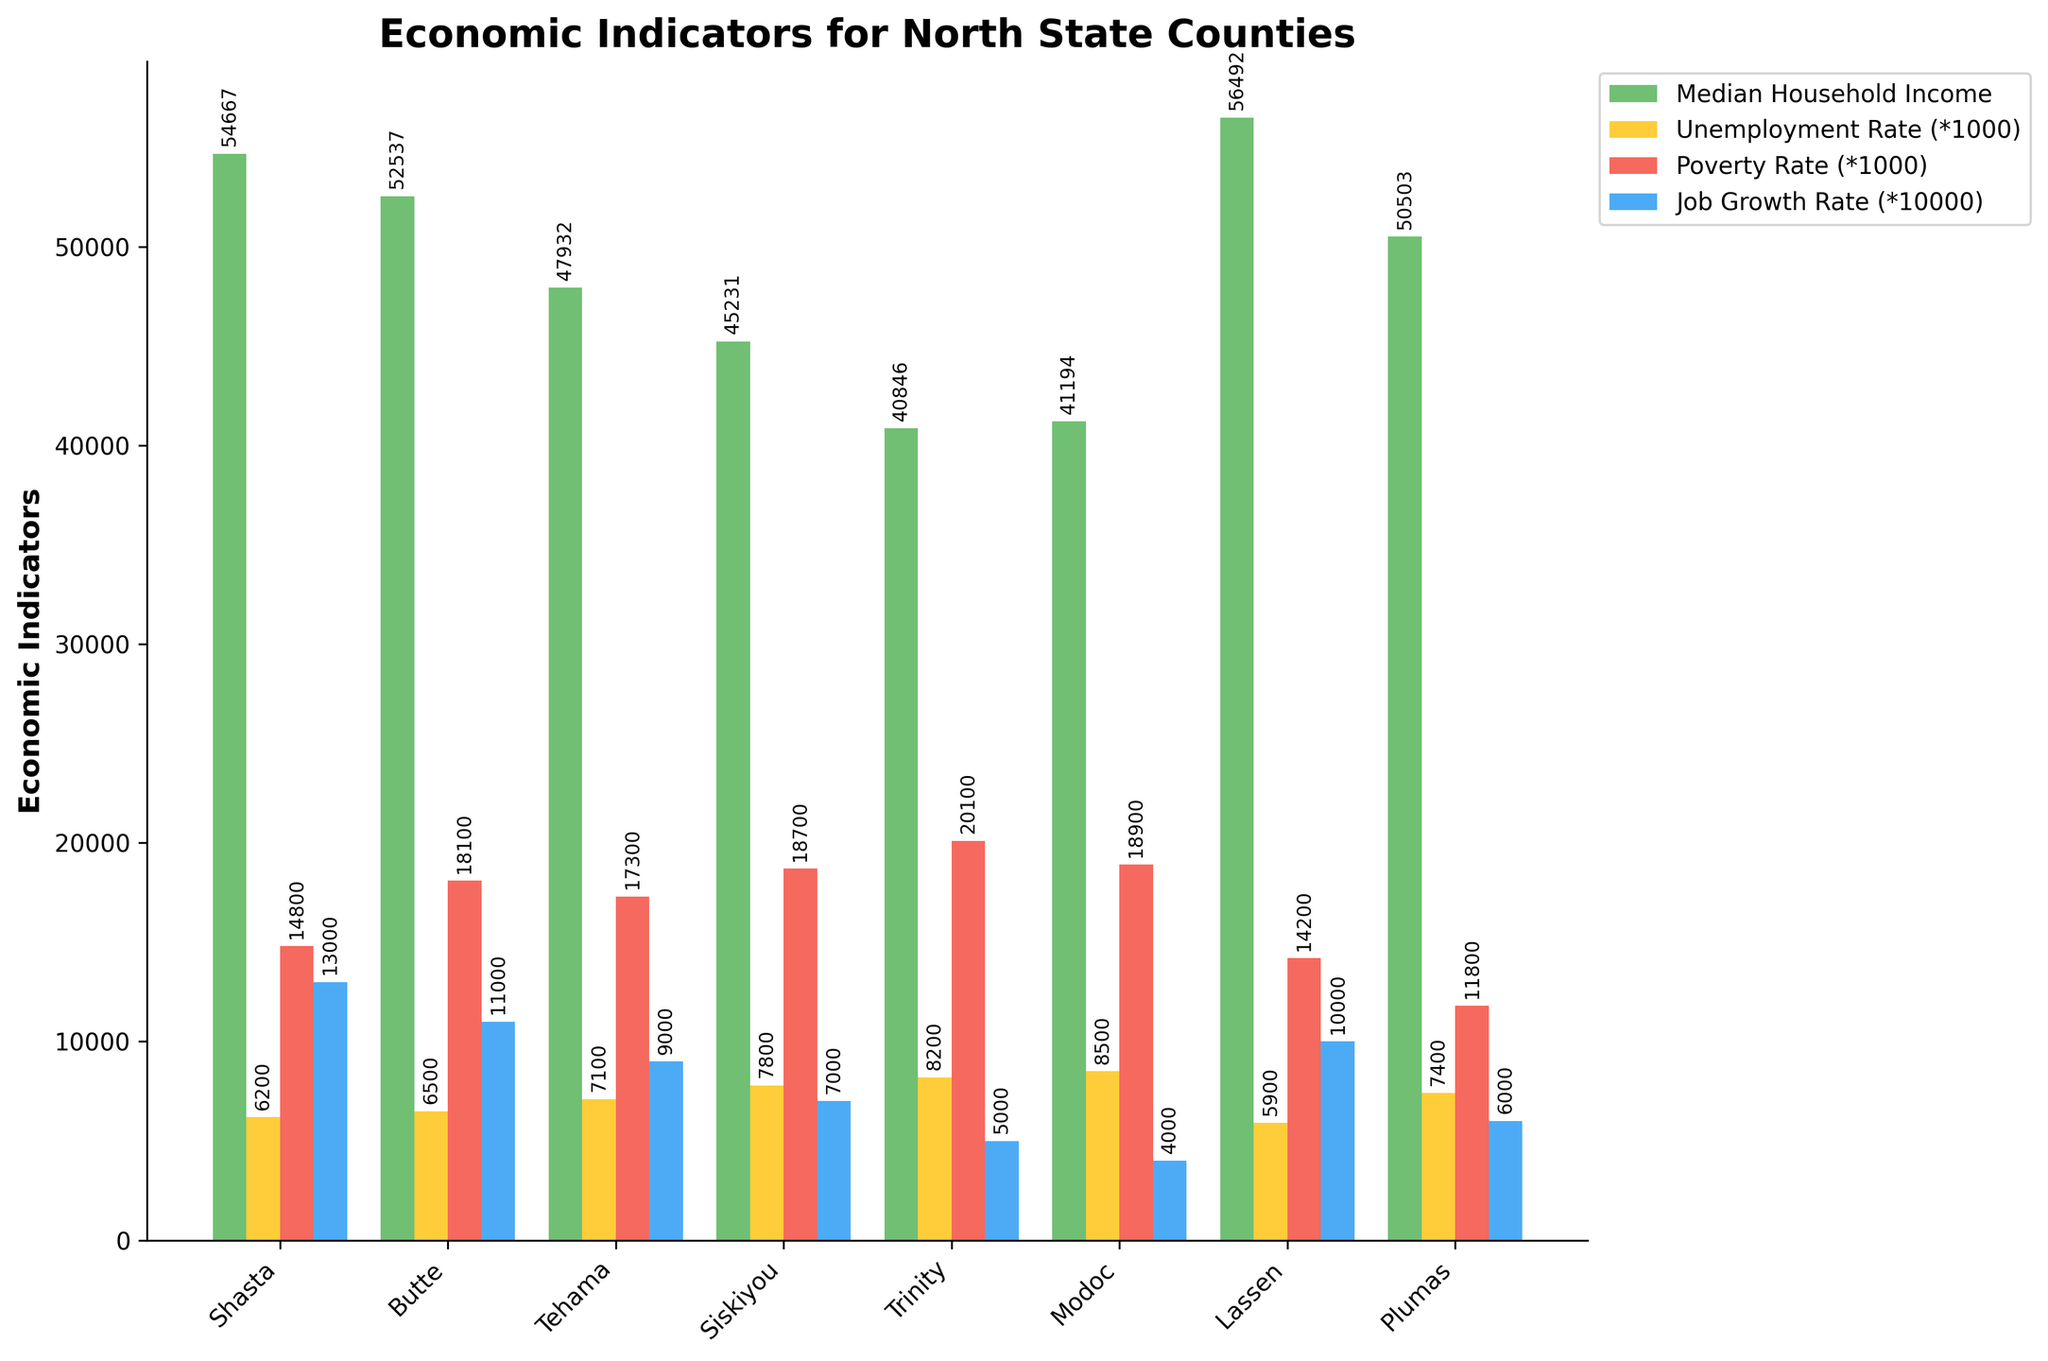Which county has the highest median household income? By looking at the heights of the green bars representing median household income, the highest bar corresponds to Lassen County.
Answer: Lassen Which county has the highest unemployment rate? By identifying the tallest yellow bar representing the unemployment rate (*1000), the tallest bar belongs to Modoc County.
Answer: Modoc What is the difference in median household income between Shasta and Siskiyou counties? Shasta County has a median household income of 54,667, while Siskiyou County has 45,231. Subtract Siskiyou's from Shasta's: 54,667 - 45,231 = 9,436.
Answer: 9,436 Which county has the lowest poverty rate? By looking at the heights of the red bars representing the poverty rate (*1000), the shortest bar belongs to Plumas County.
Answer: Plumas Which county has the highest job growth rate? By observing the tallest blue bar representing the job growth rate (*10000), the highest bar corresponds to Shasta County.
Answer: Shasta Compare the unemployment rates of Butte and Trinity counties. Which one is higher? Butte County has an unemployment rate of 6.5, while Trinity County has an unemployment rate of 8.2. Thus, Trinity has a higher rate.
Answer: Trinity Calculate the average median household income for all the counties. Sum all the median household incomes: 54,667 + 52,537 + 47,932 + 45,231 + 40,846 + 41,194 + 56,492 + 50,503. Then divide by the number of counties (8): (362,402) / 8 = 45,300.25.
Answer: 45,300.25 Which two counties have the closest poverty rates? By examining the red bars, Shasta (14.8) and Lassen (14.2) have the closest values. The difference is 14.8 - 14.2 = 0.6.
Answer: Shasta and Lassen What's the average job growth rate for Tehama and Modoc Counties? Tehama has a job growth rate of 0.9, and Modoc has 0.4. The average is (0.9 + 0.4) / 2 = 0.65.
Answer: 0.65 